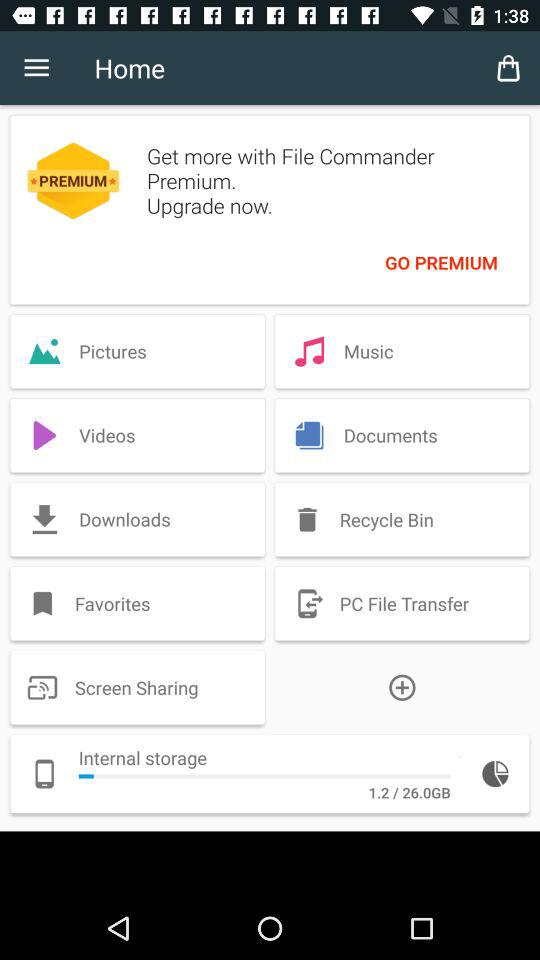How much internet storage space in total is there in the device? There is 26.0 GB of internet storage space in the device. 